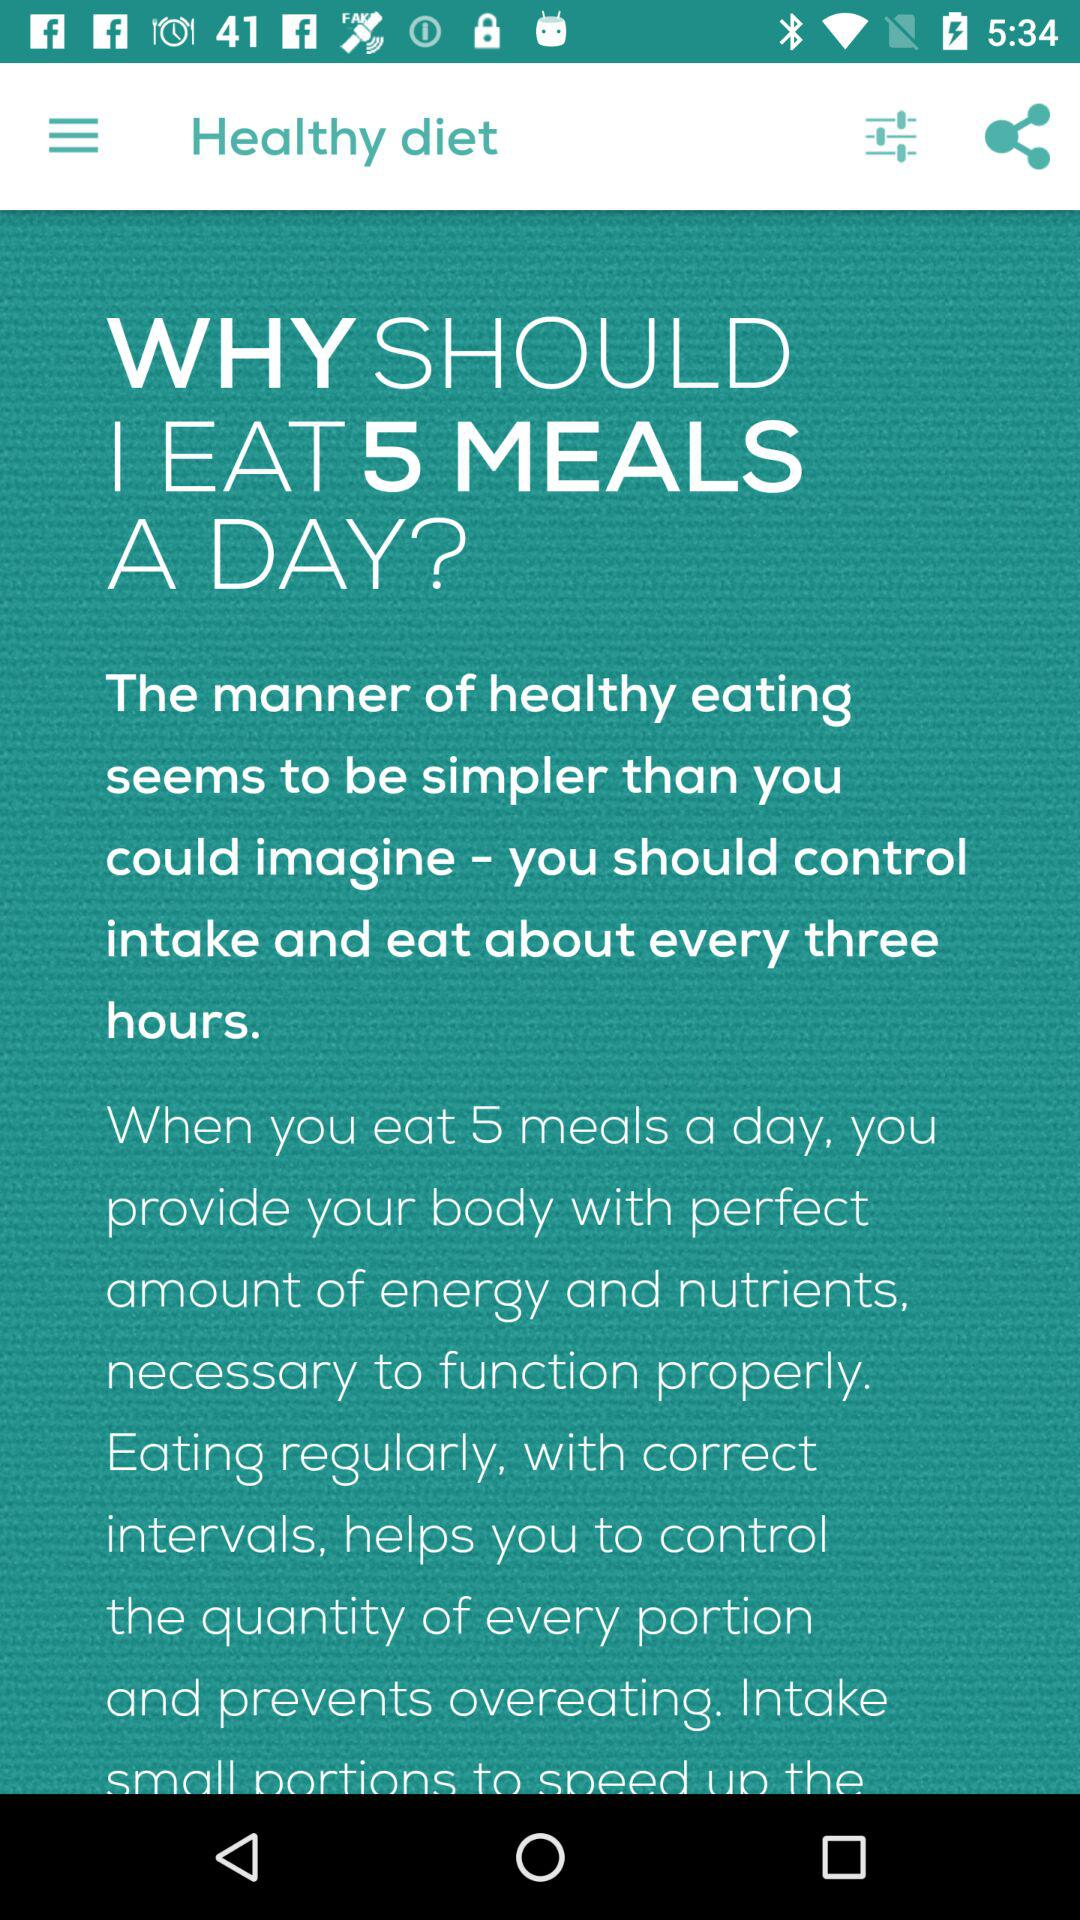What should be controlled for a healthy diet? For a healthy diet, intake should be controlled. 